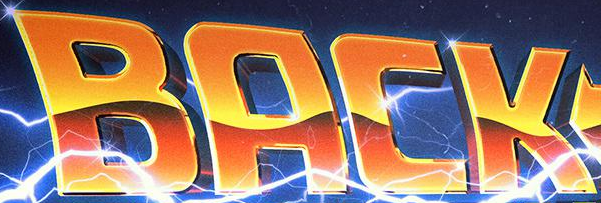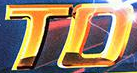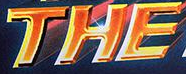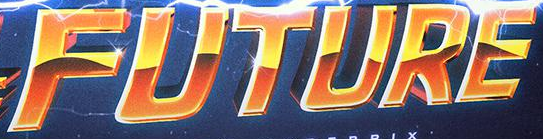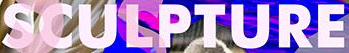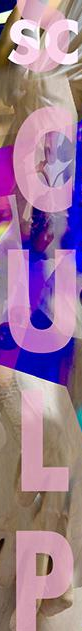What text is displayed in these images sequentially, separated by a semicolon? BACK; TO; THE; FUTURE; SCULPTURE; SCULP 